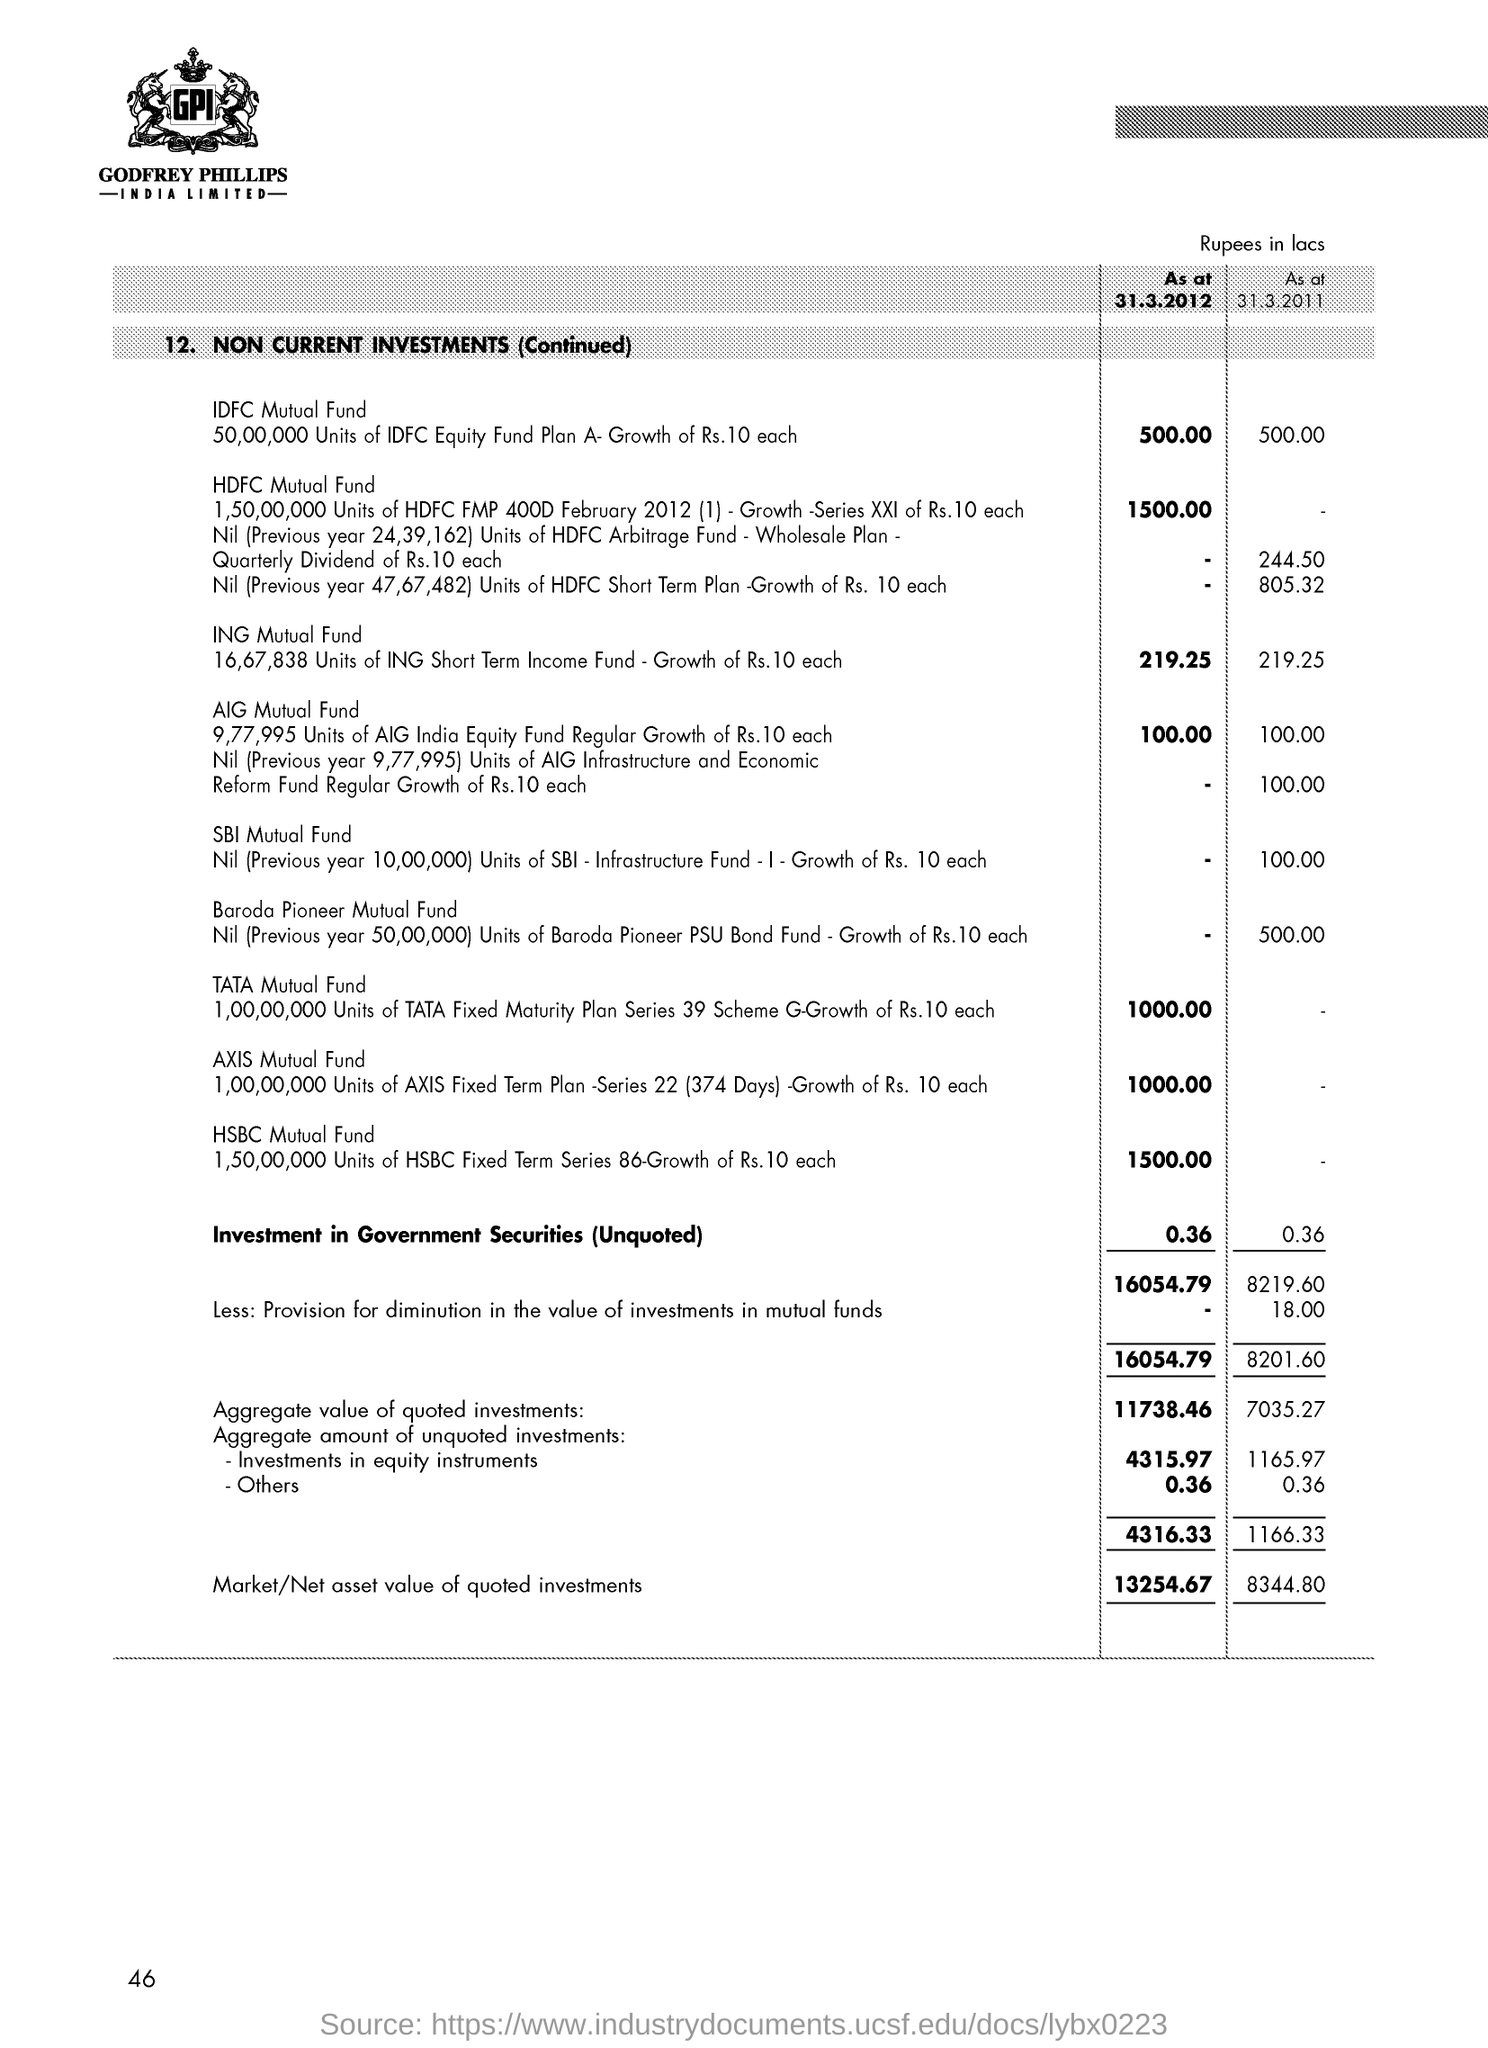Give some essential details in this illustration. As of March 31st, 2012, the idfc mutual fund was valued at 500.00. The investment in government securities (unquoted) as of 31.3.2012 was 0.36. As of March 31, 2012, the HSBC mutual fund was valued at 1,500. As of March 31, 2012, the total market or net asset value of quoted investments was 13,254.67. 